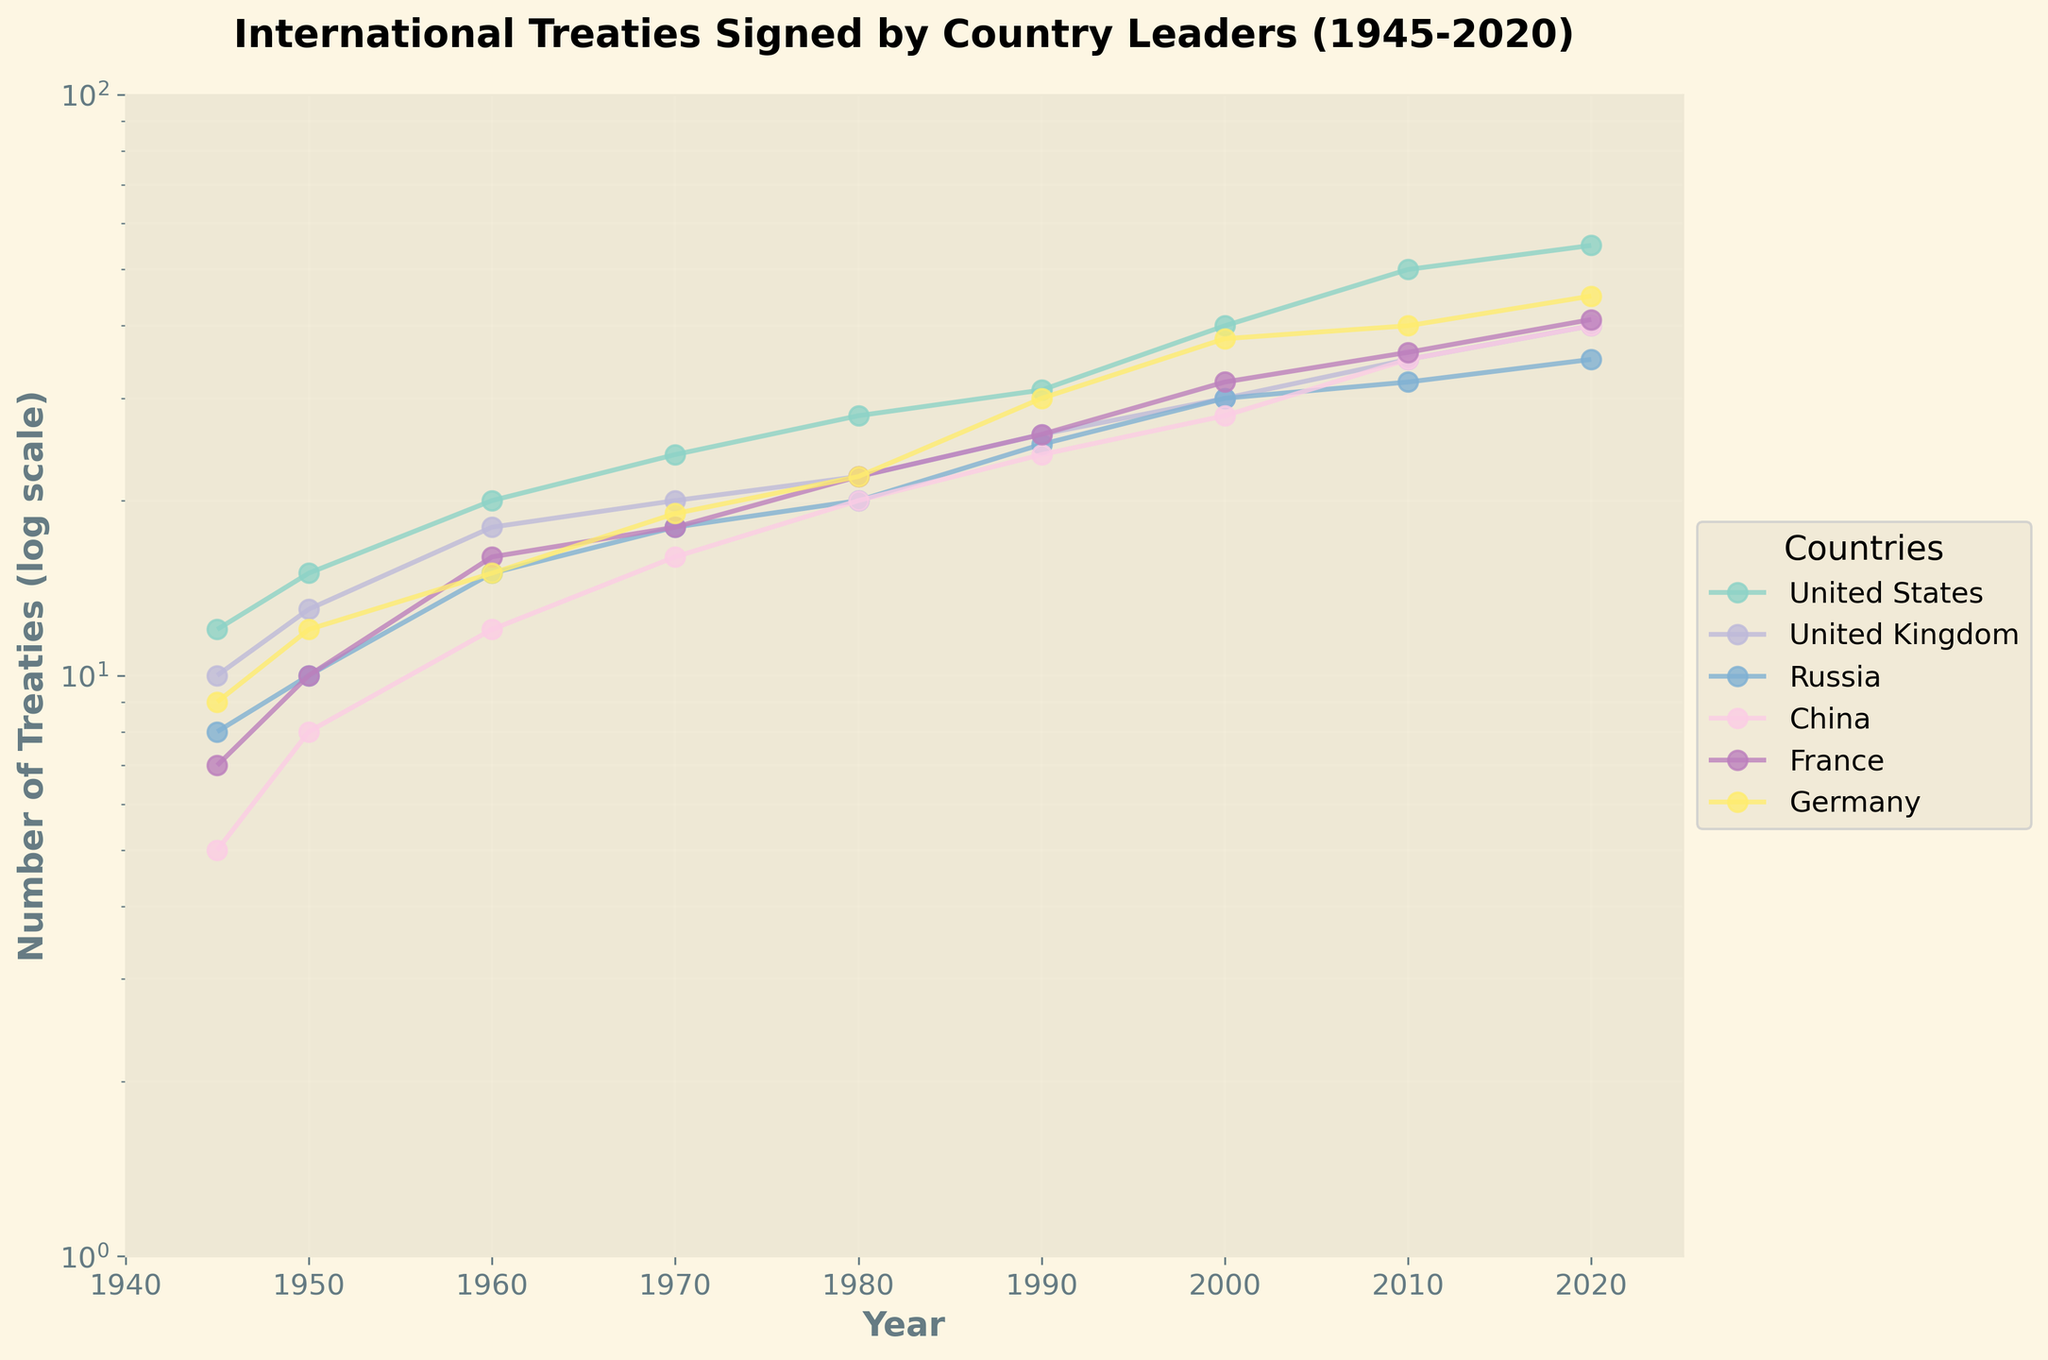What's the title of the figure? Look at the top of the plot, where a bold title is presented.
Answer: International Treaties Signed by Country Leaders (1945-2020) Which country had the most treaties signed in 2020? Look at the 2020 data points and find the country label with the highest value. The data points are labeled and given in different colors for easy identification.
Answer: United States What's the y-axis label, and what scale is used? The y-axis label can be found on the vertical axis on the left-hand side. Additionally, the scale type is mentioned next to the label.
Answer: Number of Treaties (log scale) Between which years does the figure's x-axis range span? The years spanned by the x-axis are provided at the bottom labeled axis, and the minimum and maximum years can be extracted.
Answer: 1940 to 2025 Which country showed the largest difference in the number of treaties signed from 2000 to 2010? Subtract the value at 2000 from the value at 2010 for each country and compare the differences. The largest difference identifies the country.
Answer: United States Name the countries that have shown at least 40 treaties signed by 2020. Examine the 2020 data points across all countries and check which ones reach or exceed 40 treaties. The corresponding country labels give the answer.
Answer: United States, United Kingdom, China, France, Germany How did the number of treaties signed by Russia in 1970 compare to China in the same year? Locate the data points for both Russia and China in 1970 from their respective lines and compare the values.
Answer: Russia signed more treaties than China What's the trend of the number of treaties signed by France from 1945 to 2020? Trace the line representing France from 1945 to 2020, observing whether the number of treaties signed increases, decreases or stays the same over time.
Answer: Increasing trend Which country shows the highest rate of increase in the number of treaties signed from 1945 to 2020? Calculate the rate of increase for each country from 1945 to 2020, then compare the rates. Since the chart is on a log scale, the slope of the log-linear plot can indicate the rate.
Answer: United States What is the median value of treaties signed by Germany in the years provided? Note the data points for Germany, which are mentioned numerically, then find the middle value when they are ordered. With 9 data points, the median is the 5th value in the ordering.
Answer: 19 (value at 1970) 